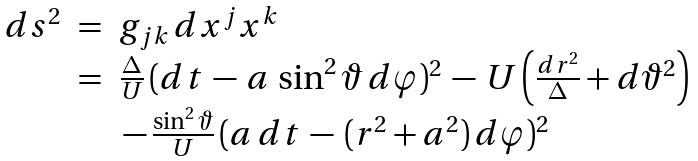<formula> <loc_0><loc_0><loc_500><loc_500>\begin{array} { l c l } d s ^ { 2 } & = & g _ { j k } \, d x ^ { j } x ^ { k } \\ & = & \frac { \Delta } { U } \, ( d t \, - \, a \, \sin ^ { 2 } \vartheta \, d \varphi ) ^ { 2 } \, - \, U \left ( \frac { d r ^ { 2 } } { \Delta } + d \vartheta ^ { 2 } \right ) \\ & & \, - \, \frac { \sin ^ { 2 } \vartheta } { U } \, ( a \, d t \, - \, ( r ^ { 2 } + a ^ { 2 } ) \, d \varphi ) ^ { 2 } \end{array}</formula> 